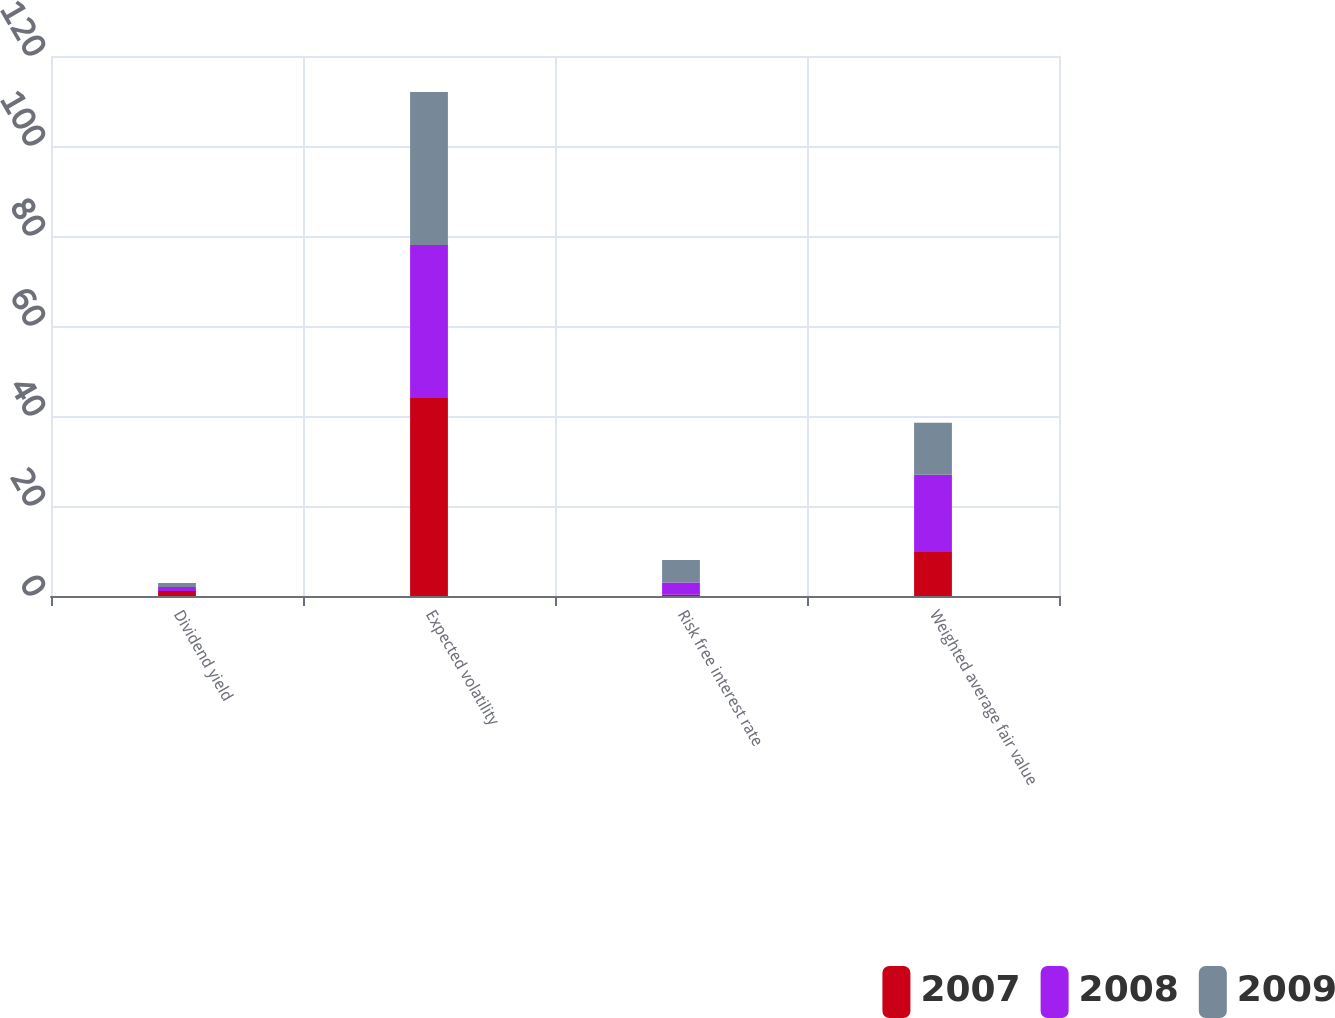Convert chart to OTSL. <chart><loc_0><loc_0><loc_500><loc_500><stacked_bar_chart><ecel><fcel>Dividend yield<fcel>Expected volatility<fcel>Risk free interest rate<fcel>Weighted average fair value<nl><fcel>2007<fcel>1.1<fcel>44<fcel>0.3<fcel>9.76<nl><fcel>2008<fcel>0.9<fcel>34<fcel>2.7<fcel>17.21<nl><fcel>2009<fcel>0.9<fcel>34<fcel>5<fcel>11.52<nl></chart> 